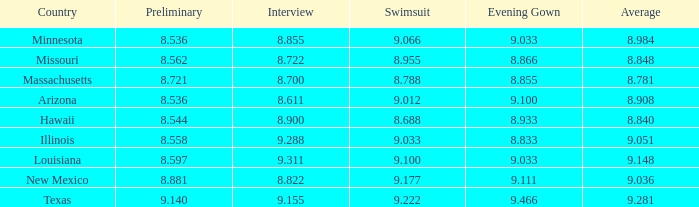What was the average score for the country with the evening gown score of 9.100? 1.0. 